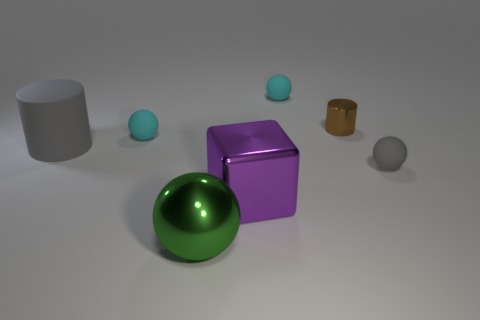The big green object has what shape?
Provide a succinct answer. Sphere. There is a small brown cylinder; what number of tiny matte objects are behind it?
Your response must be concise. 1. How many tiny brown objects have the same material as the green ball?
Give a very brief answer. 1. Are the cylinder to the left of the large purple metallic thing and the green object made of the same material?
Keep it short and to the point. No. Are any rubber cylinders visible?
Provide a succinct answer. Yes. What size is the thing that is both right of the big gray cylinder and on the left side of the shiny sphere?
Give a very brief answer. Small. Are there more purple shiny objects in front of the tiny brown cylinder than big matte things in front of the large gray matte cylinder?
Offer a very short reply. Yes. There is a sphere that is the same color as the large cylinder; what size is it?
Offer a very short reply. Small. The large block is what color?
Provide a short and direct response. Purple. There is a tiny rubber thing that is in front of the tiny brown thing and to the left of the brown metallic cylinder; what is its color?
Give a very brief answer. Cyan. 